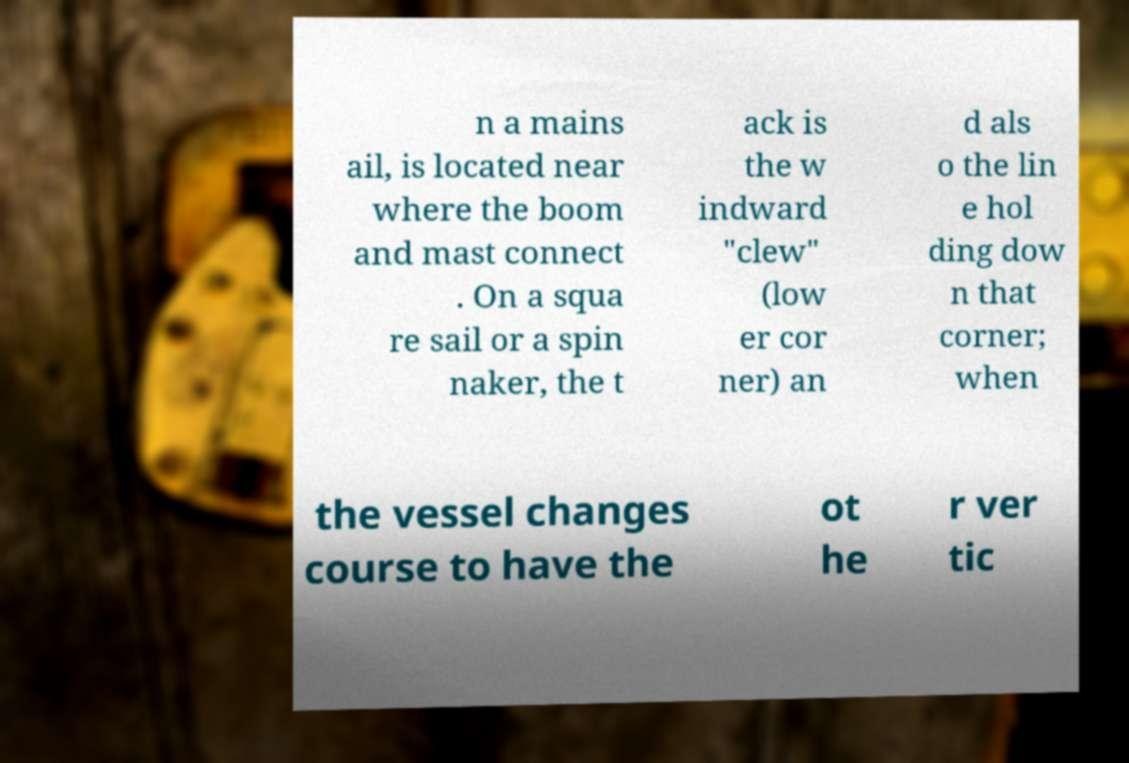Can you read and provide the text displayed in the image?This photo seems to have some interesting text. Can you extract and type it out for me? n a mains ail, is located near where the boom and mast connect . On a squa re sail or a spin naker, the t ack is the w indward "clew" (low er cor ner) an d als o the lin e hol ding dow n that corner; when the vessel changes course to have the ot he r ver tic 